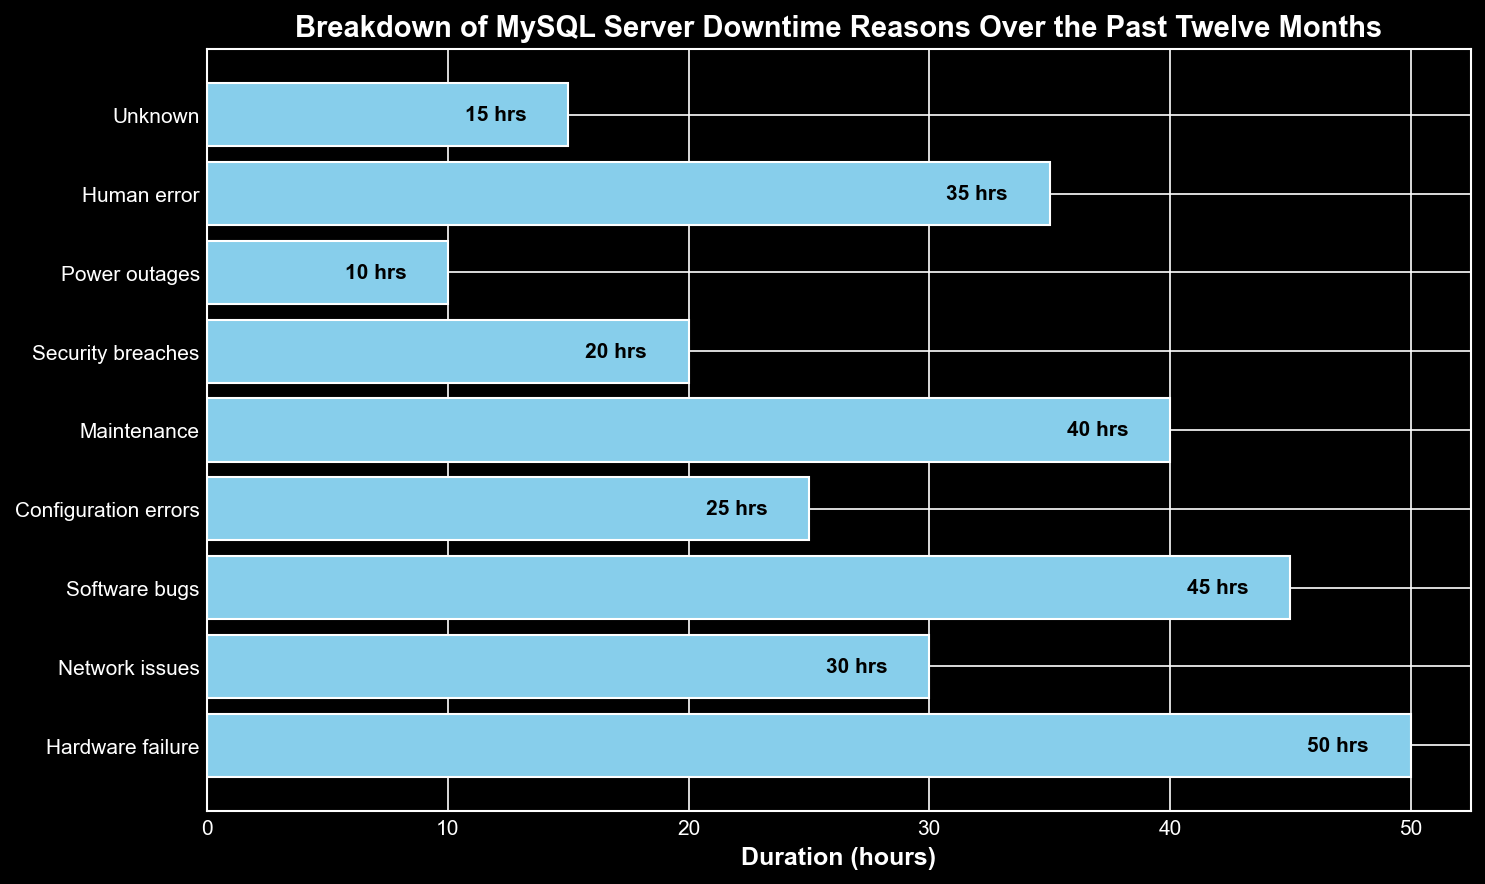What is the total duration of downtime caused by software-related issues? To find the total duration of downtime caused by software-related issues, sum the durations for Software bugs (45 hours) and Configuration errors (25 hours). 45 + 25 = 70 hours.
Answer: 70 hours Which reason accounts for the longest duration of downtime? By comparing the length of all the bars, we see that Hardware failure has the longest duration at 50 hours.
Answer: Hardware failure What is the shortest duration of downtime, and what is its reason? By looking at the length of the bars, we see that Power outages have the shortest duration at 10 hours.
Answer: 10 hours, Power outages How much more downtime did Hardware failure cause compared to Power outages? To find the difference, subtract the duration of Power outages (10 hours) from the duration of Hardware failure (50 hours). 50 - 10 = 40 hours.
Answer: 40 hours Are Configuration errors responsible for more downtime than Human error? By comparing the length of the bars, Configuration errors (25 hours) caused less downtime than Human error (35 hours).
Answer: No Which reasons caused downtime of exactly 45 hours or higher? Scan through the bars and identify those with durations of 45 hours or more: Hardware failure (50 hours) and Software bugs (45 hours).
Answer: Hardware failure, Software bugs How does the duration of downtime caused by Maintenance compare to Network issues? Maintenance caused 40 hours of downtime, whereas Network issues caused 30 hours. Maintenance caused 10 hours more downtime.
Answer: Maintenance caused more What is the average duration of downtime across all reasons? Sum the total duration of all reasons (50+30+45+25+40+20+10+35+15 = 270 hours) and divide by the number of reasons (9). The average is 270 / 9 = 30 hours.
Answer: 30 hours What are the combined durations of downtime due to Network issues and Security breaches? Add the durations for Network issues (30 hours) and Security breaches (20 hours). 30 + 20 = 50 hours.
Answer: 50 hours 